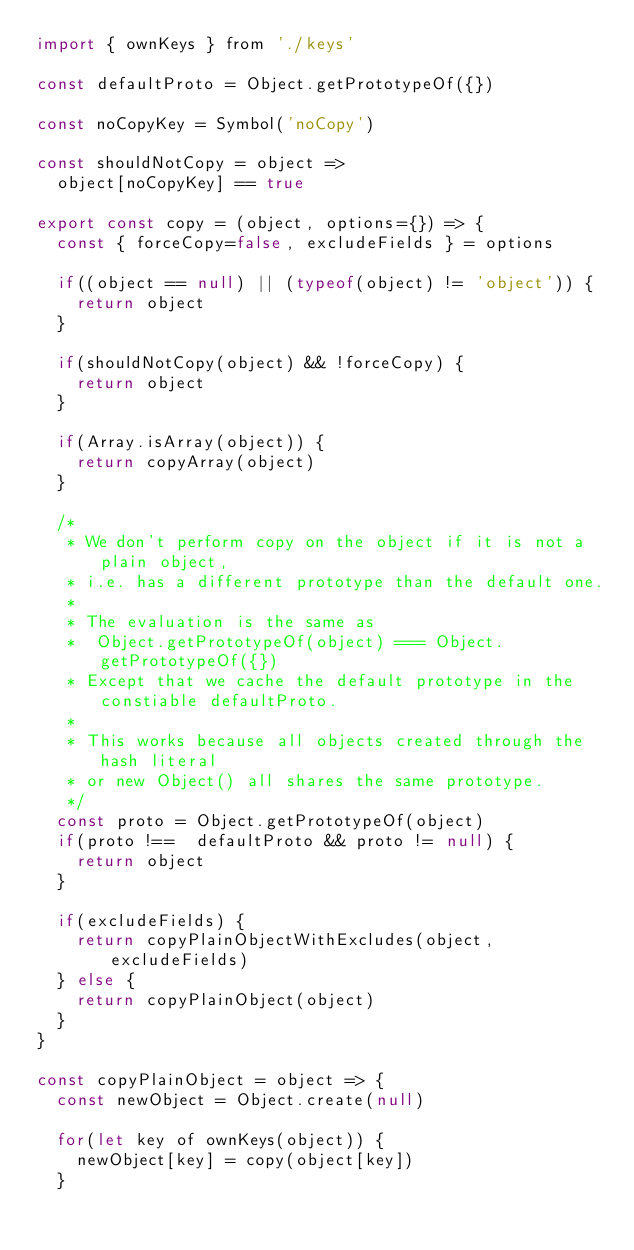Convert code to text. <code><loc_0><loc_0><loc_500><loc_500><_JavaScript_>import { ownKeys } from './keys'

const defaultProto = Object.getPrototypeOf({})

const noCopyKey = Symbol('noCopy')

const shouldNotCopy = object =>
  object[noCopyKey] == true

export const copy = (object, options={}) => {
  const { forceCopy=false, excludeFields } = options

  if((object == null) || (typeof(object) != 'object')) {
    return object
  }

  if(shouldNotCopy(object) && !forceCopy) {
    return object
  }

  if(Array.isArray(object)) {
    return copyArray(object)
  }

  /*
   * We don't perform copy on the object if it is not a plain object,
   * i.e. has a different prototype than the default one.
   *
   * The evaluation is the same as
   *  Object.getPrototypeOf(object) === Object.getPrototypeOf({})
   * Except that we cache the default prototype in the constiable defaultProto.
   *
   * This works because all objects created through the hash literal
   * or new Object() all shares the same prototype.
   */
  const proto = Object.getPrototypeOf(object)
  if(proto !==  defaultProto && proto != null) {
    return object
  }

  if(excludeFields) {
    return copyPlainObjectWithExcludes(object, excludeFields)
  } else {
    return copyPlainObject(object)
  }
}

const copyPlainObject = object => {
  const newObject = Object.create(null)

  for(let key of ownKeys(object)) {
    newObject[key] = copy(object[key])
  }
</code> 